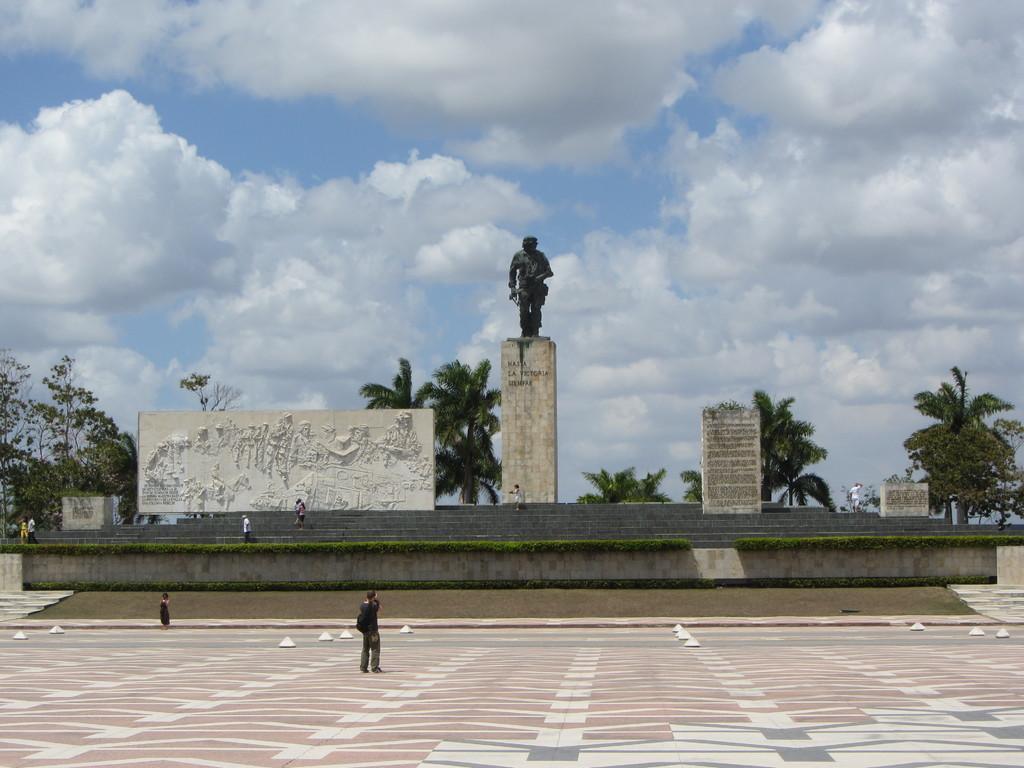Can you describe this image briefly? This image is clicked outside. There are trees in the middle. There is a statue in the middle. There are some persons on the left side. There is sky at the top. 